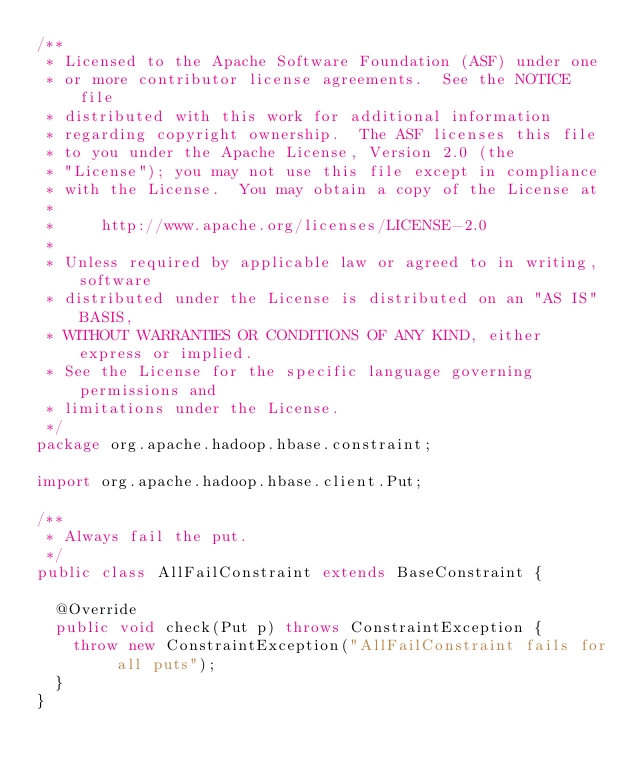Convert code to text. <code><loc_0><loc_0><loc_500><loc_500><_Java_>/**
 * Licensed to the Apache Software Foundation (ASF) under one
 * or more contributor license agreements.  See the NOTICE file
 * distributed with this work for additional information
 * regarding copyright ownership.  The ASF licenses this file
 * to you under the Apache License, Version 2.0 (the
 * "License"); you may not use this file except in compliance
 * with the License.  You may obtain a copy of the License at
 *
 *     http://www.apache.org/licenses/LICENSE-2.0
 *
 * Unless required by applicable law or agreed to in writing, software
 * distributed under the License is distributed on an "AS IS" BASIS,
 * WITHOUT WARRANTIES OR CONDITIONS OF ANY KIND, either express or implied.
 * See the License for the specific language governing permissions and
 * limitations under the License.
 */
package org.apache.hadoop.hbase.constraint;

import org.apache.hadoop.hbase.client.Put;

/**
 * Always fail the put.
 */
public class AllFailConstraint extends BaseConstraint {

  @Override
  public void check(Put p) throws ConstraintException {
    throw new ConstraintException("AllFailConstraint fails for all puts");
  }
}
</code> 